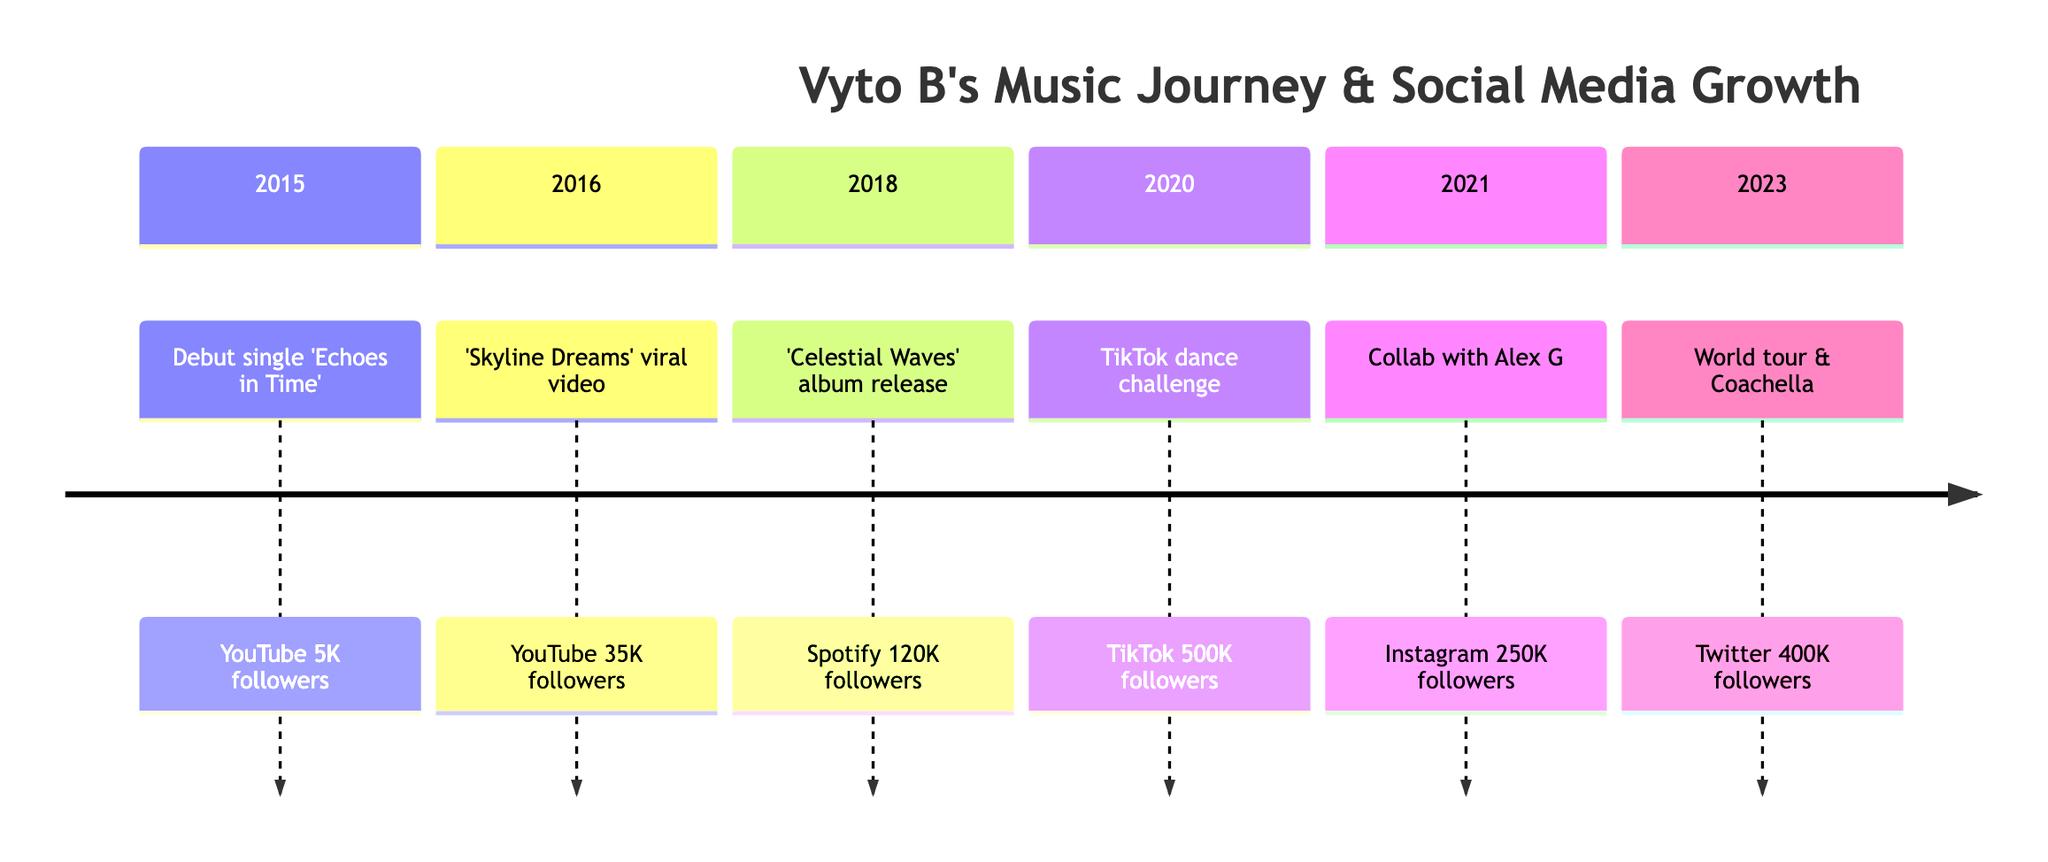What year did Vyto B release his debut single? The timeline shows that the debut single 'Echoes in Time' was released in 2015.
Answer: 2015 How many followers did Vyto B have on YouTube in 2016? According to the diagram, in 2016, following the viral moment of 'Skyline Dreams', Vyto B had 35,000 followers on YouTube.
Answer: 35,000 What was the event associated with the highest number of followers on TikTok? The diagram indicates that the TikTok dance challenge featuring 'Rhythmic River' in 2020 led to 500,000 followers, which is the highest on TikTok.
Answer: TikTok dance challenge Which platform gained Vyto B the most followers in 2018? The timeline indicates that in 2018, the release of the debut album 'Celestial Waves' on Spotify resulted in 120,000 followers, marking it as the most followers gained that year.
Answer: Spotify In what year did Vyto B collaborate with Alex G? According to the timeline, the collaboration with Alex G on the single 'Stellar Nights' occurred in 2021.
Answer: 2021 What was the follower count on Instagram in 2021? The diagram indicates that in 2021, after the collaboration with Alex G, Vyto B had 250,000 followers on Instagram.
Answer: 250,000 Which event in the timeline marks the first significant social media growth on TikTok? The diagram shows that the significant social media growth on TikTok first occurred in 2020 with the dance challenge for 'Rhythmic River'.
Answer: Dance challenge What was Vyto B's follower count on Twitter in 2023? The timeline reveals that in 2023, following the announcement of a world tour and Coachella performance, Vyto B had 400,000 followers on Twitter.
Answer: 400,000 